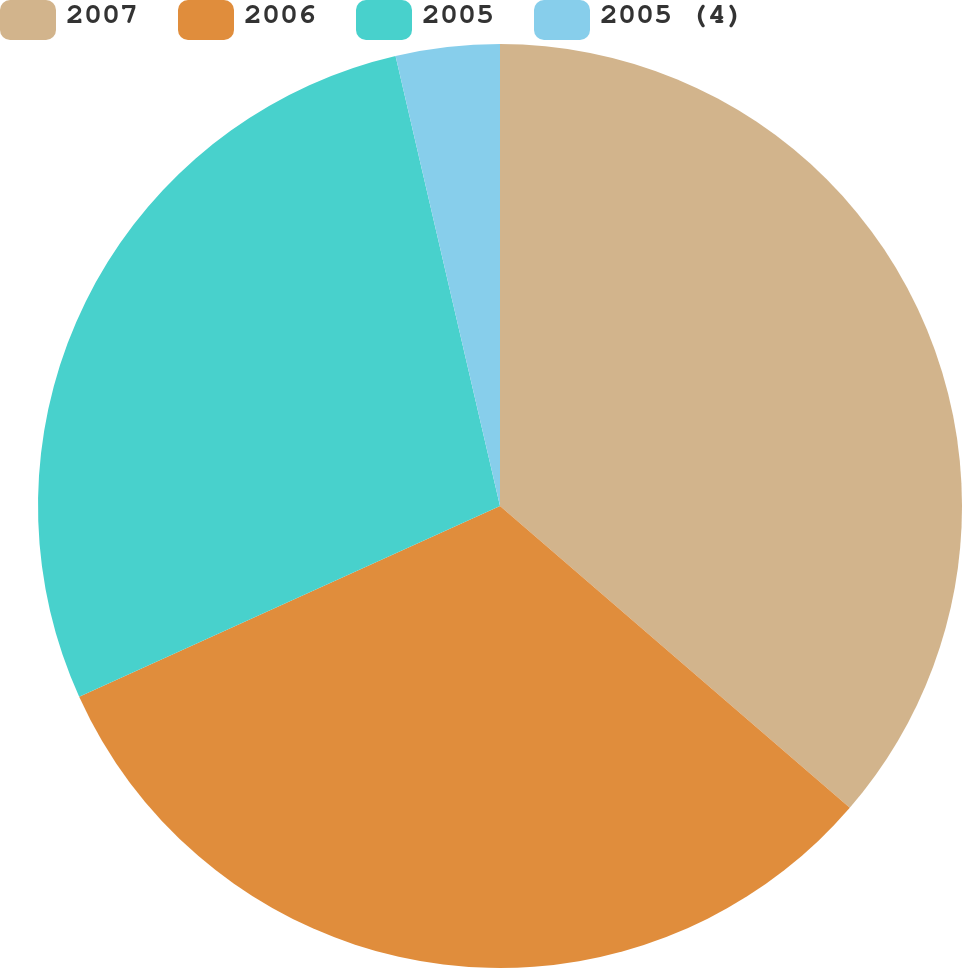<chart> <loc_0><loc_0><loc_500><loc_500><pie_chart><fcel>2007<fcel>2006<fcel>2005<fcel>2005 (4)<nl><fcel>36.33%<fcel>31.9%<fcel>28.14%<fcel>3.63%<nl></chart> 